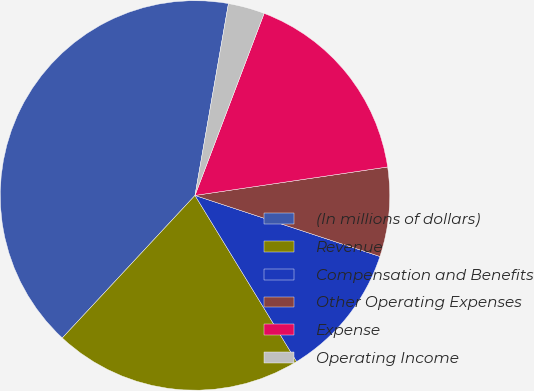<chart> <loc_0><loc_0><loc_500><loc_500><pie_chart><fcel>(In millions of dollars)<fcel>Revenue<fcel>Compensation and Benefits<fcel>Other Operating Expenses<fcel>Expense<fcel>Operating Income<nl><fcel>40.82%<fcel>20.67%<fcel>11.19%<fcel>7.41%<fcel>16.89%<fcel>3.03%<nl></chart> 